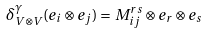<formula> <loc_0><loc_0><loc_500><loc_500>\delta _ { V \otimes V } ^ { \gamma } ( e _ { i } \otimes e _ { j } ) = M _ { i j } ^ { r s } \otimes e _ { r } \otimes e _ { s }</formula> 